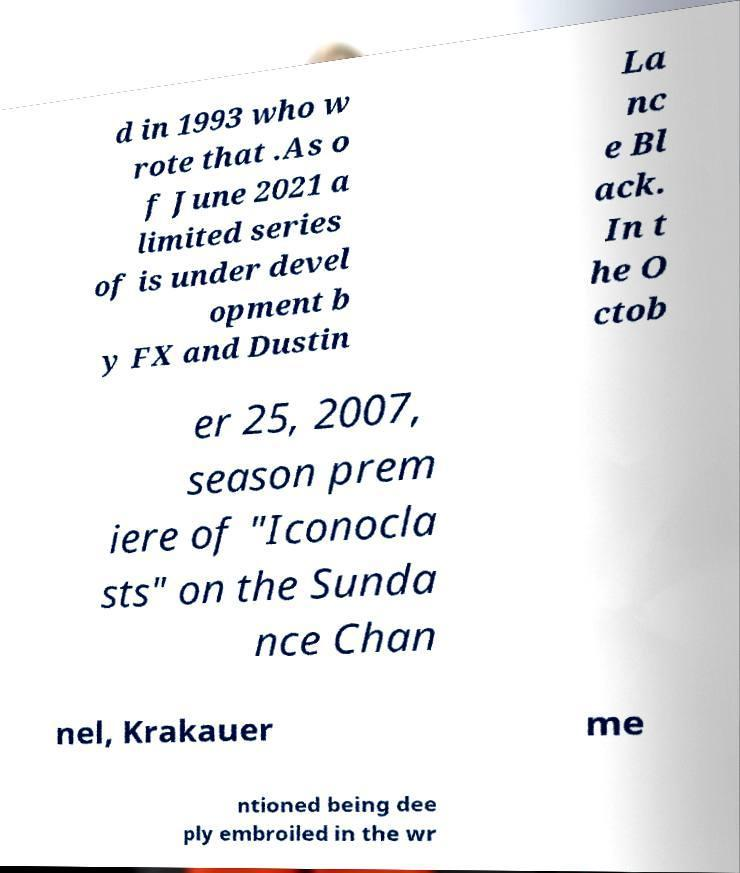There's text embedded in this image that I need extracted. Can you transcribe it verbatim? d in 1993 who w rote that .As o f June 2021 a limited series of is under devel opment b y FX and Dustin La nc e Bl ack. In t he O ctob er 25, 2007, season prem iere of "Iconocla sts" on the Sunda nce Chan nel, Krakauer me ntioned being dee ply embroiled in the wr 